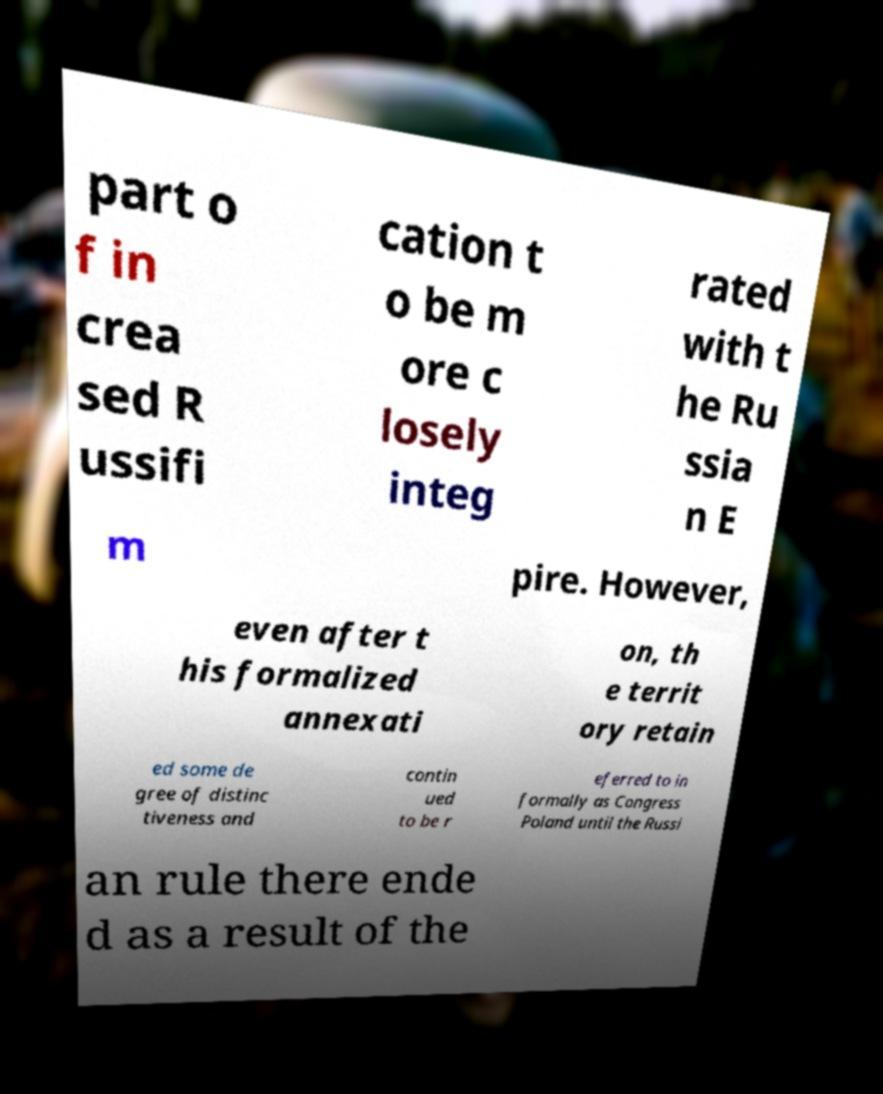There's text embedded in this image that I need extracted. Can you transcribe it verbatim? part o f in crea sed R ussifi cation t o be m ore c losely integ rated with t he Ru ssia n E m pire. However, even after t his formalized annexati on, th e territ ory retain ed some de gree of distinc tiveness and contin ued to be r eferred to in formally as Congress Poland until the Russi an rule there ende d as a result of the 